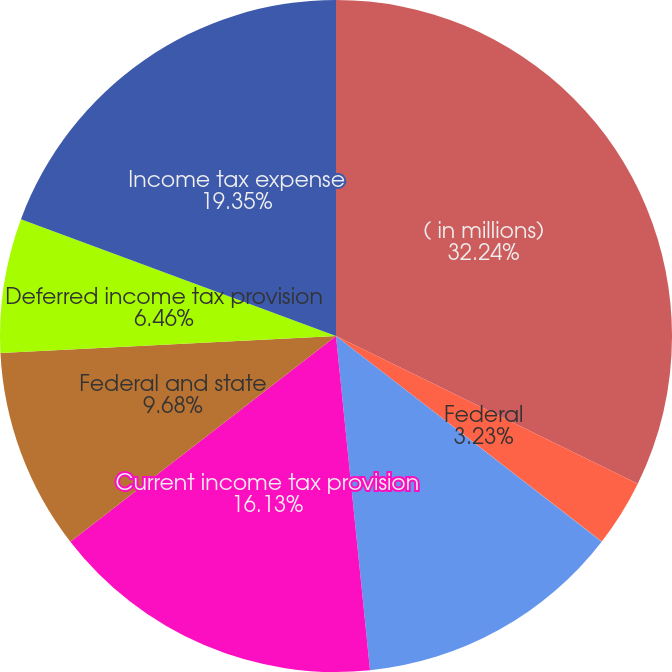<chart> <loc_0><loc_0><loc_500><loc_500><pie_chart><fcel>( in millions)<fcel>Federal<fcel>State<fcel>International<fcel>Current income tax provision<fcel>Federal and state<fcel>Deferred income tax provision<fcel>Income tax expense<nl><fcel>32.25%<fcel>3.23%<fcel>0.01%<fcel>12.9%<fcel>16.13%<fcel>9.68%<fcel>6.46%<fcel>19.35%<nl></chart> 